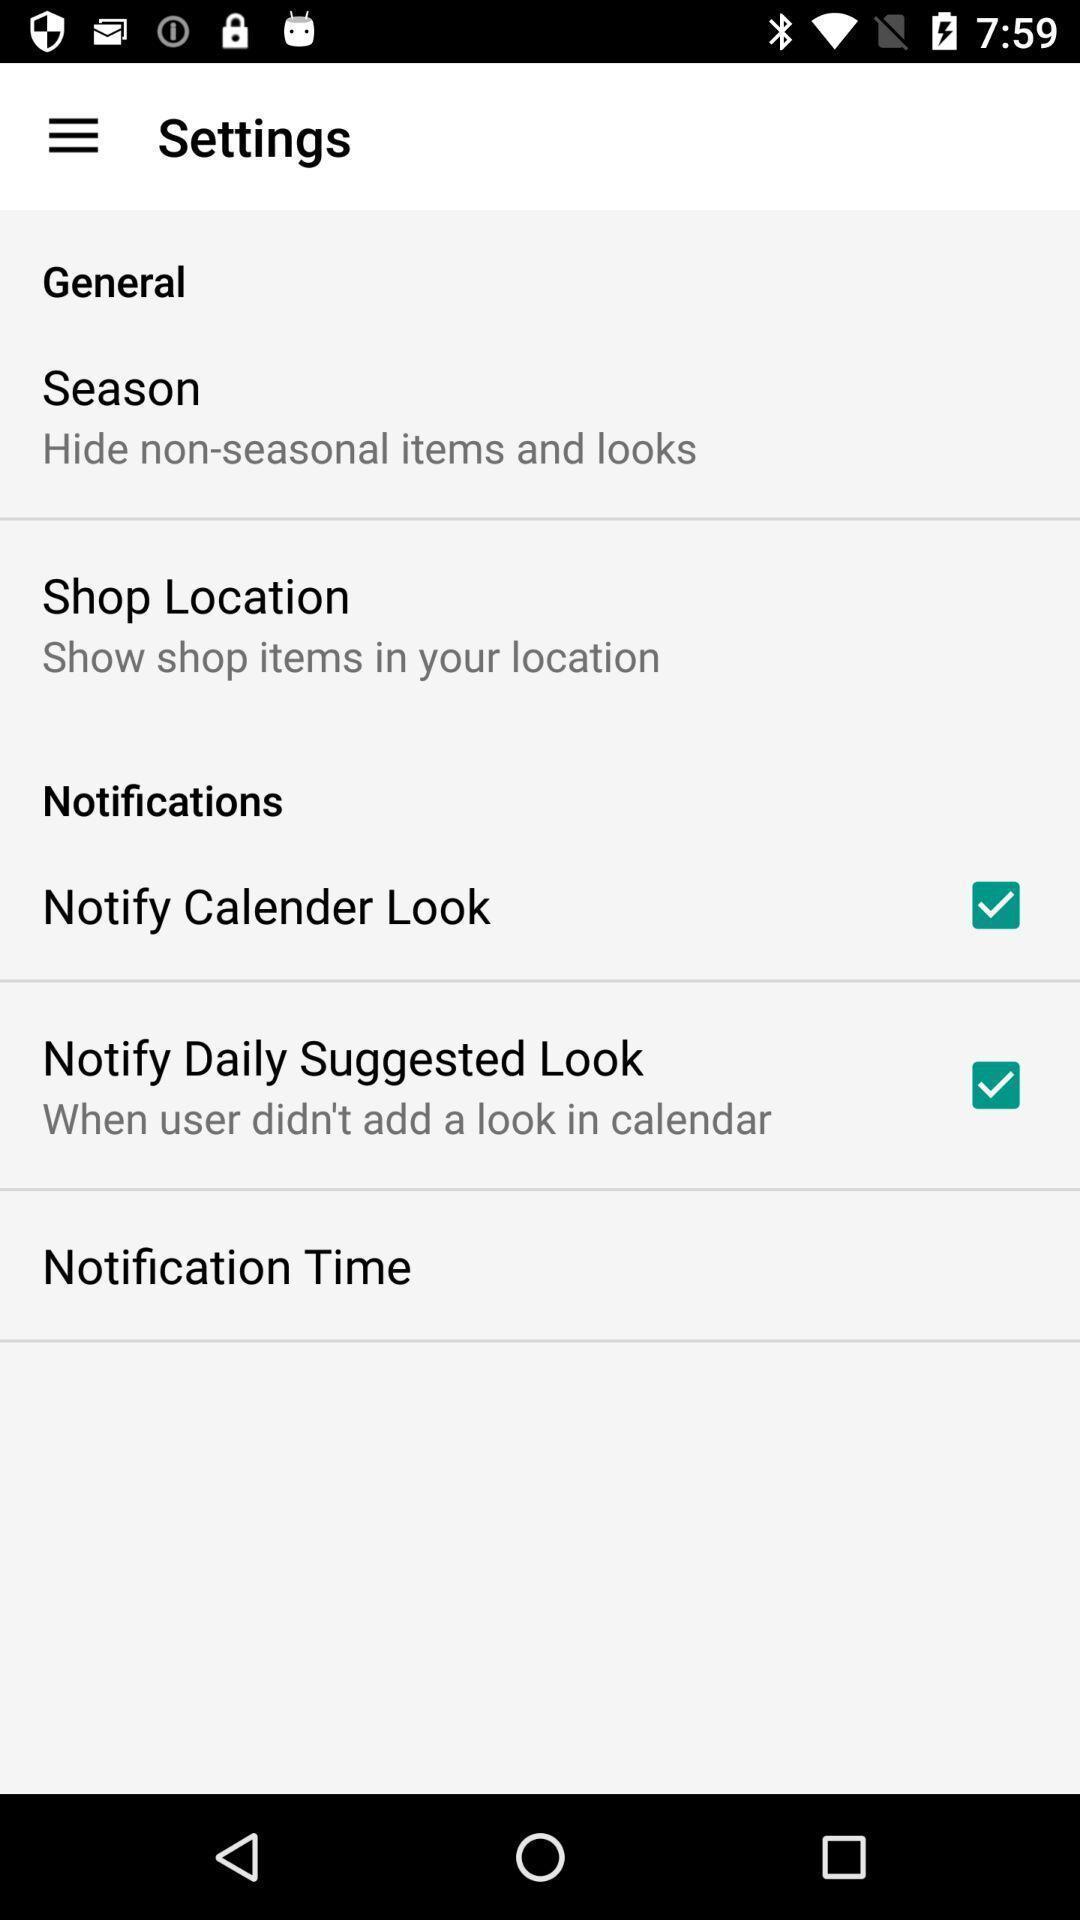What can you discern from this picture? Settings page. 